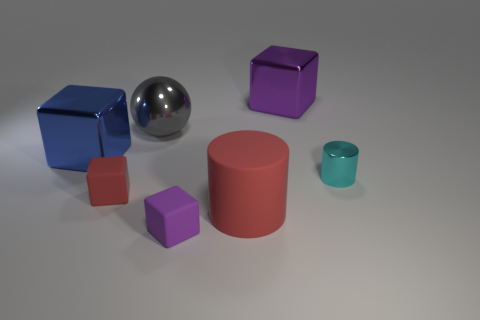Is there anything else that is the same shape as the big gray metallic object?
Your answer should be compact. No. There is a small thing on the right side of the large metal block that is right of the big metallic object left of the small red object; what is its shape?
Provide a short and direct response. Cylinder. How many other things are the same color as the small metallic object?
Ensure brevity in your answer.  0. Are there more purple objects that are in front of the large gray thing than metal balls in front of the red matte block?
Offer a terse response. Yes. Are there any metal cubes to the right of the red block?
Ensure brevity in your answer.  Yes. What is the material of the object that is both to the right of the gray metal thing and behind the blue object?
Give a very brief answer. Metal. There is a matte object that is the same shape as the small cyan metal object; what color is it?
Your response must be concise. Red. Is there a small red matte thing that is to the left of the rubber block that is on the left side of the small purple matte cube?
Your answer should be very brief. No. How big is the shiny cylinder?
Make the answer very short. Small. There is a matte object that is both on the left side of the rubber cylinder and in front of the small red cube; what shape is it?
Ensure brevity in your answer.  Cube. 